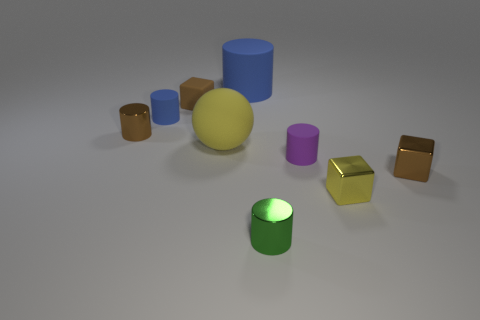How many cylinders are either rubber things or tiny purple objects?
Offer a very short reply. 3. There is a cube behind the tiny brown metallic object right of the metal thing left of the tiny brown rubber block; what size is it?
Provide a succinct answer. Small. What is the shape of the blue matte object that is the same size as the green shiny object?
Ensure brevity in your answer.  Cylinder. There is a yellow matte object; what shape is it?
Make the answer very short. Sphere. Are the small brown object that is on the right side of the yellow matte sphere and the yellow cube made of the same material?
Give a very brief answer. Yes. What size is the cube that is behind the small matte cylinder that is to the right of the tiny green cylinder?
Make the answer very short. Small. The small block that is behind the tiny yellow metal object and in front of the brown metal cylinder is what color?
Make the answer very short. Brown. There is a blue thing that is the same size as the yellow metallic object; what material is it?
Keep it short and to the point. Rubber. What number of other things are there of the same material as the tiny purple object
Ensure brevity in your answer.  4. Does the tiny block left of the green thing have the same color as the cylinder in front of the purple rubber object?
Give a very brief answer. No. 